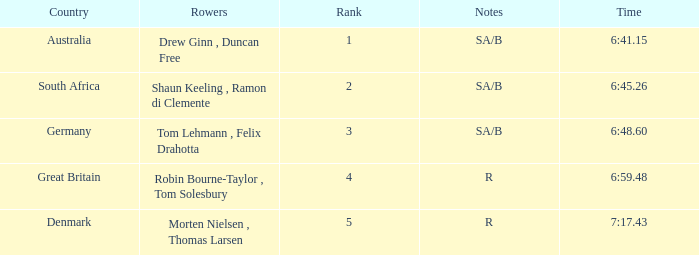What was the highest rank for rowers who represented Denmark? 5.0. 